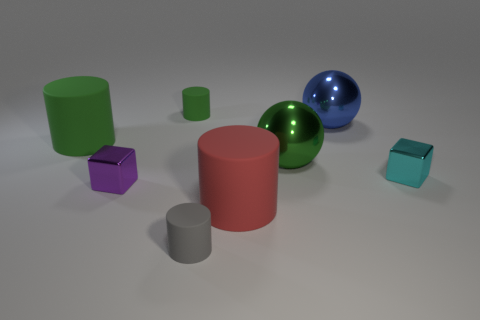There is a tiny gray thing that is the same shape as the large red thing; what is its material?
Provide a succinct answer. Rubber. There is a large matte thing to the right of the tiny gray rubber cylinder; what number of objects are behind it?
Give a very brief answer. 6. What number of things are either cyan metal cubes or blocks that are to the left of the big red matte thing?
Give a very brief answer. 2. What material is the small object that is left of the small matte object left of the gray cylinder in front of the small purple metallic object?
Ensure brevity in your answer.  Metal. What size is the red cylinder that is the same material as the gray cylinder?
Provide a succinct answer. Large. What is the color of the large cylinder on the left side of the small rubber cylinder that is behind the small purple metal block?
Provide a succinct answer. Green. What number of large things are the same material as the small purple cube?
Give a very brief answer. 2. How many rubber objects are either big cylinders or gray cylinders?
Offer a terse response. 3. What is the material of the blue thing that is the same size as the green shiny ball?
Keep it short and to the point. Metal. Is there a big ball that has the same material as the small green thing?
Your answer should be very brief. No. 